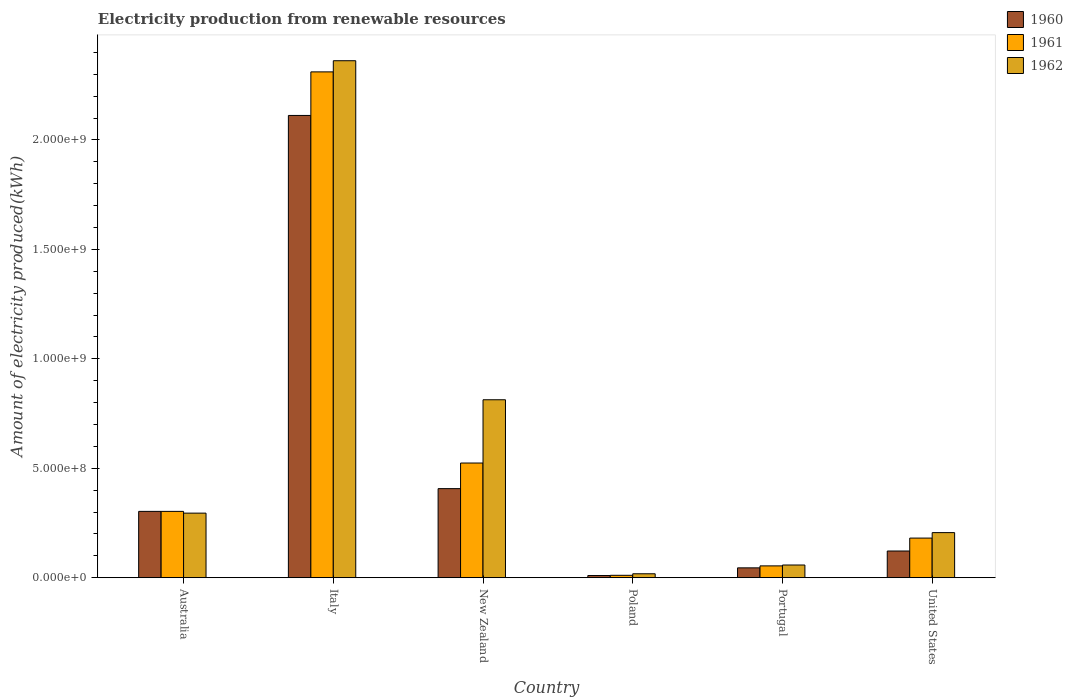How many different coloured bars are there?
Give a very brief answer. 3. How many bars are there on the 2nd tick from the left?
Provide a short and direct response. 3. What is the label of the 5th group of bars from the left?
Give a very brief answer. Portugal. In how many cases, is the number of bars for a given country not equal to the number of legend labels?
Ensure brevity in your answer.  0. What is the amount of electricity produced in 1961 in Italy?
Your response must be concise. 2.31e+09. Across all countries, what is the maximum amount of electricity produced in 1962?
Your answer should be compact. 2.36e+09. Across all countries, what is the minimum amount of electricity produced in 1962?
Ensure brevity in your answer.  1.80e+07. In which country was the amount of electricity produced in 1960 minimum?
Give a very brief answer. Poland. What is the total amount of electricity produced in 1961 in the graph?
Provide a short and direct response. 3.38e+09. What is the difference between the amount of electricity produced in 1960 in Italy and that in Poland?
Your response must be concise. 2.10e+09. What is the difference between the amount of electricity produced in 1960 in Portugal and the amount of electricity produced in 1961 in Poland?
Keep it short and to the point. 3.40e+07. What is the average amount of electricity produced in 1962 per country?
Your response must be concise. 6.25e+08. What is the difference between the amount of electricity produced of/in 1961 and amount of electricity produced of/in 1960 in Portugal?
Keep it short and to the point. 9.00e+06. In how many countries, is the amount of electricity produced in 1962 greater than 1900000000 kWh?
Ensure brevity in your answer.  1. What is the ratio of the amount of electricity produced in 1961 in New Zealand to that in Portugal?
Your answer should be very brief. 9.7. Is the difference between the amount of electricity produced in 1961 in New Zealand and Poland greater than the difference between the amount of electricity produced in 1960 in New Zealand and Poland?
Keep it short and to the point. Yes. What is the difference between the highest and the second highest amount of electricity produced in 1962?
Your response must be concise. 1.55e+09. What is the difference between the highest and the lowest amount of electricity produced in 1962?
Provide a succinct answer. 2.34e+09. In how many countries, is the amount of electricity produced in 1960 greater than the average amount of electricity produced in 1960 taken over all countries?
Provide a short and direct response. 1. What does the 1st bar from the left in Portugal represents?
Your answer should be very brief. 1960. What does the 3rd bar from the right in Portugal represents?
Provide a succinct answer. 1960. How many countries are there in the graph?
Provide a succinct answer. 6. How many legend labels are there?
Your answer should be very brief. 3. What is the title of the graph?
Provide a succinct answer. Electricity production from renewable resources. What is the label or title of the Y-axis?
Offer a terse response. Amount of electricity produced(kWh). What is the Amount of electricity produced(kWh) in 1960 in Australia?
Keep it short and to the point. 3.03e+08. What is the Amount of electricity produced(kWh) in 1961 in Australia?
Give a very brief answer. 3.03e+08. What is the Amount of electricity produced(kWh) in 1962 in Australia?
Keep it short and to the point. 2.95e+08. What is the Amount of electricity produced(kWh) of 1960 in Italy?
Provide a short and direct response. 2.11e+09. What is the Amount of electricity produced(kWh) in 1961 in Italy?
Keep it short and to the point. 2.31e+09. What is the Amount of electricity produced(kWh) in 1962 in Italy?
Make the answer very short. 2.36e+09. What is the Amount of electricity produced(kWh) of 1960 in New Zealand?
Offer a terse response. 4.07e+08. What is the Amount of electricity produced(kWh) in 1961 in New Zealand?
Keep it short and to the point. 5.24e+08. What is the Amount of electricity produced(kWh) of 1962 in New Zealand?
Give a very brief answer. 8.13e+08. What is the Amount of electricity produced(kWh) in 1960 in Poland?
Your answer should be very brief. 1.00e+07. What is the Amount of electricity produced(kWh) of 1961 in Poland?
Ensure brevity in your answer.  1.10e+07. What is the Amount of electricity produced(kWh) of 1962 in Poland?
Make the answer very short. 1.80e+07. What is the Amount of electricity produced(kWh) of 1960 in Portugal?
Your answer should be very brief. 4.50e+07. What is the Amount of electricity produced(kWh) of 1961 in Portugal?
Your response must be concise. 5.40e+07. What is the Amount of electricity produced(kWh) in 1962 in Portugal?
Give a very brief answer. 5.80e+07. What is the Amount of electricity produced(kWh) in 1960 in United States?
Your answer should be compact. 1.22e+08. What is the Amount of electricity produced(kWh) in 1961 in United States?
Ensure brevity in your answer.  1.81e+08. What is the Amount of electricity produced(kWh) of 1962 in United States?
Give a very brief answer. 2.06e+08. Across all countries, what is the maximum Amount of electricity produced(kWh) in 1960?
Give a very brief answer. 2.11e+09. Across all countries, what is the maximum Amount of electricity produced(kWh) in 1961?
Offer a terse response. 2.31e+09. Across all countries, what is the maximum Amount of electricity produced(kWh) of 1962?
Ensure brevity in your answer.  2.36e+09. Across all countries, what is the minimum Amount of electricity produced(kWh) of 1961?
Your response must be concise. 1.10e+07. Across all countries, what is the minimum Amount of electricity produced(kWh) of 1962?
Provide a succinct answer. 1.80e+07. What is the total Amount of electricity produced(kWh) of 1960 in the graph?
Keep it short and to the point. 3.00e+09. What is the total Amount of electricity produced(kWh) of 1961 in the graph?
Provide a short and direct response. 3.38e+09. What is the total Amount of electricity produced(kWh) in 1962 in the graph?
Your response must be concise. 3.75e+09. What is the difference between the Amount of electricity produced(kWh) of 1960 in Australia and that in Italy?
Your answer should be compact. -1.81e+09. What is the difference between the Amount of electricity produced(kWh) of 1961 in Australia and that in Italy?
Keep it short and to the point. -2.01e+09. What is the difference between the Amount of electricity produced(kWh) in 1962 in Australia and that in Italy?
Keep it short and to the point. -2.07e+09. What is the difference between the Amount of electricity produced(kWh) of 1960 in Australia and that in New Zealand?
Provide a short and direct response. -1.04e+08. What is the difference between the Amount of electricity produced(kWh) in 1961 in Australia and that in New Zealand?
Your response must be concise. -2.21e+08. What is the difference between the Amount of electricity produced(kWh) of 1962 in Australia and that in New Zealand?
Make the answer very short. -5.18e+08. What is the difference between the Amount of electricity produced(kWh) of 1960 in Australia and that in Poland?
Ensure brevity in your answer.  2.93e+08. What is the difference between the Amount of electricity produced(kWh) in 1961 in Australia and that in Poland?
Provide a short and direct response. 2.92e+08. What is the difference between the Amount of electricity produced(kWh) of 1962 in Australia and that in Poland?
Your response must be concise. 2.77e+08. What is the difference between the Amount of electricity produced(kWh) in 1960 in Australia and that in Portugal?
Keep it short and to the point. 2.58e+08. What is the difference between the Amount of electricity produced(kWh) of 1961 in Australia and that in Portugal?
Provide a succinct answer. 2.49e+08. What is the difference between the Amount of electricity produced(kWh) of 1962 in Australia and that in Portugal?
Your response must be concise. 2.37e+08. What is the difference between the Amount of electricity produced(kWh) of 1960 in Australia and that in United States?
Offer a very short reply. 1.81e+08. What is the difference between the Amount of electricity produced(kWh) of 1961 in Australia and that in United States?
Provide a short and direct response. 1.22e+08. What is the difference between the Amount of electricity produced(kWh) in 1962 in Australia and that in United States?
Your answer should be very brief. 8.90e+07. What is the difference between the Amount of electricity produced(kWh) in 1960 in Italy and that in New Zealand?
Make the answer very short. 1.70e+09. What is the difference between the Amount of electricity produced(kWh) in 1961 in Italy and that in New Zealand?
Ensure brevity in your answer.  1.79e+09. What is the difference between the Amount of electricity produced(kWh) in 1962 in Italy and that in New Zealand?
Offer a very short reply. 1.55e+09. What is the difference between the Amount of electricity produced(kWh) in 1960 in Italy and that in Poland?
Your answer should be compact. 2.10e+09. What is the difference between the Amount of electricity produced(kWh) in 1961 in Italy and that in Poland?
Your answer should be very brief. 2.30e+09. What is the difference between the Amount of electricity produced(kWh) in 1962 in Italy and that in Poland?
Provide a short and direct response. 2.34e+09. What is the difference between the Amount of electricity produced(kWh) of 1960 in Italy and that in Portugal?
Your answer should be very brief. 2.07e+09. What is the difference between the Amount of electricity produced(kWh) in 1961 in Italy and that in Portugal?
Keep it short and to the point. 2.26e+09. What is the difference between the Amount of electricity produced(kWh) of 1962 in Italy and that in Portugal?
Give a very brief answer. 2.30e+09. What is the difference between the Amount of electricity produced(kWh) of 1960 in Italy and that in United States?
Provide a succinct answer. 1.99e+09. What is the difference between the Amount of electricity produced(kWh) of 1961 in Italy and that in United States?
Ensure brevity in your answer.  2.13e+09. What is the difference between the Amount of electricity produced(kWh) in 1962 in Italy and that in United States?
Provide a succinct answer. 2.16e+09. What is the difference between the Amount of electricity produced(kWh) in 1960 in New Zealand and that in Poland?
Offer a very short reply. 3.97e+08. What is the difference between the Amount of electricity produced(kWh) of 1961 in New Zealand and that in Poland?
Offer a terse response. 5.13e+08. What is the difference between the Amount of electricity produced(kWh) of 1962 in New Zealand and that in Poland?
Provide a succinct answer. 7.95e+08. What is the difference between the Amount of electricity produced(kWh) in 1960 in New Zealand and that in Portugal?
Your answer should be very brief. 3.62e+08. What is the difference between the Amount of electricity produced(kWh) in 1961 in New Zealand and that in Portugal?
Offer a terse response. 4.70e+08. What is the difference between the Amount of electricity produced(kWh) of 1962 in New Zealand and that in Portugal?
Give a very brief answer. 7.55e+08. What is the difference between the Amount of electricity produced(kWh) in 1960 in New Zealand and that in United States?
Your response must be concise. 2.85e+08. What is the difference between the Amount of electricity produced(kWh) in 1961 in New Zealand and that in United States?
Make the answer very short. 3.43e+08. What is the difference between the Amount of electricity produced(kWh) of 1962 in New Zealand and that in United States?
Your answer should be very brief. 6.07e+08. What is the difference between the Amount of electricity produced(kWh) in 1960 in Poland and that in Portugal?
Your response must be concise. -3.50e+07. What is the difference between the Amount of electricity produced(kWh) in 1961 in Poland and that in Portugal?
Offer a very short reply. -4.30e+07. What is the difference between the Amount of electricity produced(kWh) in 1962 in Poland and that in Portugal?
Your answer should be very brief. -4.00e+07. What is the difference between the Amount of electricity produced(kWh) of 1960 in Poland and that in United States?
Offer a very short reply. -1.12e+08. What is the difference between the Amount of electricity produced(kWh) in 1961 in Poland and that in United States?
Give a very brief answer. -1.70e+08. What is the difference between the Amount of electricity produced(kWh) in 1962 in Poland and that in United States?
Offer a terse response. -1.88e+08. What is the difference between the Amount of electricity produced(kWh) of 1960 in Portugal and that in United States?
Offer a very short reply. -7.70e+07. What is the difference between the Amount of electricity produced(kWh) of 1961 in Portugal and that in United States?
Make the answer very short. -1.27e+08. What is the difference between the Amount of electricity produced(kWh) of 1962 in Portugal and that in United States?
Offer a very short reply. -1.48e+08. What is the difference between the Amount of electricity produced(kWh) in 1960 in Australia and the Amount of electricity produced(kWh) in 1961 in Italy?
Your response must be concise. -2.01e+09. What is the difference between the Amount of electricity produced(kWh) in 1960 in Australia and the Amount of electricity produced(kWh) in 1962 in Italy?
Your answer should be very brief. -2.06e+09. What is the difference between the Amount of electricity produced(kWh) of 1961 in Australia and the Amount of electricity produced(kWh) of 1962 in Italy?
Your answer should be very brief. -2.06e+09. What is the difference between the Amount of electricity produced(kWh) of 1960 in Australia and the Amount of electricity produced(kWh) of 1961 in New Zealand?
Offer a very short reply. -2.21e+08. What is the difference between the Amount of electricity produced(kWh) in 1960 in Australia and the Amount of electricity produced(kWh) in 1962 in New Zealand?
Your answer should be very brief. -5.10e+08. What is the difference between the Amount of electricity produced(kWh) of 1961 in Australia and the Amount of electricity produced(kWh) of 1962 in New Zealand?
Your answer should be compact. -5.10e+08. What is the difference between the Amount of electricity produced(kWh) of 1960 in Australia and the Amount of electricity produced(kWh) of 1961 in Poland?
Ensure brevity in your answer.  2.92e+08. What is the difference between the Amount of electricity produced(kWh) of 1960 in Australia and the Amount of electricity produced(kWh) of 1962 in Poland?
Provide a succinct answer. 2.85e+08. What is the difference between the Amount of electricity produced(kWh) in 1961 in Australia and the Amount of electricity produced(kWh) in 1962 in Poland?
Ensure brevity in your answer.  2.85e+08. What is the difference between the Amount of electricity produced(kWh) in 1960 in Australia and the Amount of electricity produced(kWh) in 1961 in Portugal?
Your answer should be compact. 2.49e+08. What is the difference between the Amount of electricity produced(kWh) in 1960 in Australia and the Amount of electricity produced(kWh) in 1962 in Portugal?
Provide a succinct answer. 2.45e+08. What is the difference between the Amount of electricity produced(kWh) in 1961 in Australia and the Amount of electricity produced(kWh) in 1962 in Portugal?
Give a very brief answer. 2.45e+08. What is the difference between the Amount of electricity produced(kWh) of 1960 in Australia and the Amount of electricity produced(kWh) of 1961 in United States?
Provide a succinct answer. 1.22e+08. What is the difference between the Amount of electricity produced(kWh) of 1960 in Australia and the Amount of electricity produced(kWh) of 1962 in United States?
Give a very brief answer. 9.70e+07. What is the difference between the Amount of electricity produced(kWh) of 1961 in Australia and the Amount of electricity produced(kWh) of 1962 in United States?
Your response must be concise. 9.70e+07. What is the difference between the Amount of electricity produced(kWh) of 1960 in Italy and the Amount of electricity produced(kWh) of 1961 in New Zealand?
Your answer should be compact. 1.59e+09. What is the difference between the Amount of electricity produced(kWh) of 1960 in Italy and the Amount of electricity produced(kWh) of 1962 in New Zealand?
Provide a short and direct response. 1.30e+09. What is the difference between the Amount of electricity produced(kWh) in 1961 in Italy and the Amount of electricity produced(kWh) in 1962 in New Zealand?
Ensure brevity in your answer.  1.50e+09. What is the difference between the Amount of electricity produced(kWh) in 1960 in Italy and the Amount of electricity produced(kWh) in 1961 in Poland?
Keep it short and to the point. 2.10e+09. What is the difference between the Amount of electricity produced(kWh) in 1960 in Italy and the Amount of electricity produced(kWh) in 1962 in Poland?
Provide a short and direct response. 2.09e+09. What is the difference between the Amount of electricity produced(kWh) of 1961 in Italy and the Amount of electricity produced(kWh) of 1962 in Poland?
Keep it short and to the point. 2.29e+09. What is the difference between the Amount of electricity produced(kWh) of 1960 in Italy and the Amount of electricity produced(kWh) of 1961 in Portugal?
Offer a terse response. 2.06e+09. What is the difference between the Amount of electricity produced(kWh) in 1960 in Italy and the Amount of electricity produced(kWh) in 1962 in Portugal?
Offer a very short reply. 2.05e+09. What is the difference between the Amount of electricity produced(kWh) of 1961 in Italy and the Amount of electricity produced(kWh) of 1962 in Portugal?
Your answer should be very brief. 2.25e+09. What is the difference between the Amount of electricity produced(kWh) in 1960 in Italy and the Amount of electricity produced(kWh) in 1961 in United States?
Give a very brief answer. 1.93e+09. What is the difference between the Amount of electricity produced(kWh) of 1960 in Italy and the Amount of electricity produced(kWh) of 1962 in United States?
Your answer should be very brief. 1.91e+09. What is the difference between the Amount of electricity produced(kWh) of 1961 in Italy and the Amount of electricity produced(kWh) of 1962 in United States?
Your answer should be very brief. 2.10e+09. What is the difference between the Amount of electricity produced(kWh) in 1960 in New Zealand and the Amount of electricity produced(kWh) in 1961 in Poland?
Ensure brevity in your answer.  3.96e+08. What is the difference between the Amount of electricity produced(kWh) of 1960 in New Zealand and the Amount of electricity produced(kWh) of 1962 in Poland?
Your answer should be compact. 3.89e+08. What is the difference between the Amount of electricity produced(kWh) of 1961 in New Zealand and the Amount of electricity produced(kWh) of 1962 in Poland?
Your answer should be very brief. 5.06e+08. What is the difference between the Amount of electricity produced(kWh) in 1960 in New Zealand and the Amount of electricity produced(kWh) in 1961 in Portugal?
Ensure brevity in your answer.  3.53e+08. What is the difference between the Amount of electricity produced(kWh) of 1960 in New Zealand and the Amount of electricity produced(kWh) of 1962 in Portugal?
Make the answer very short. 3.49e+08. What is the difference between the Amount of electricity produced(kWh) in 1961 in New Zealand and the Amount of electricity produced(kWh) in 1962 in Portugal?
Offer a very short reply. 4.66e+08. What is the difference between the Amount of electricity produced(kWh) of 1960 in New Zealand and the Amount of electricity produced(kWh) of 1961 in United States?
Provide a short and direct response. 2.26e+08. What is the difference between the Amount of electricity produced(kWh) of 1960 in New Zealand and the Amount of electricity produced(kWh) of 1962 in United States?
Offer a terse response. 2.01e+08. What is the difference between the Amount of electricity produced(kWh) of 1961 in New Zealand and the Amount of electricity produced(kWh) of 1962 in United States?
Make the answer very short. 3.18e+08. What is the difference between the Amount of electricity produced(kWh) in 1960 in Poland and the Amount of electricity produced(kWh) in 1961 in Portugal?
Give a very brief answer. -4.40e+07. What is the difference between the Amount of electricity produced(kWh) in 1960 in Poland and the Amount of electricity produced(kWh) in 1962 in Portugal?
Your answer should be very brief. -4.80e+07. What is the difference between the Amount of electricity produced(kWh) of 1961 in Poland and the Amount of electricity produced(kWh) of 1962 in Portugal?
Your answer should be compact. -4.70e+07. What is the difference between the Amount of electricity produced(kWh) in 1960 in Poland and the Amount of electricity produced(kWh) in 1961 in United States?
Make the answer very short. -1.71e+08. What is the difference between the Amount of electricity produced(kWh) of 1960 in Poland and the Amount of electricity produced(kWh) of 1962 in United States?
Keep it short and to the point. -1.96e+08. What is the difference between the Amount of electricity produced(kWh) of 1961 in Poland and the Amount of electricity produced(kWh) of 1962 in United States?
Provide a short and direct response. -1.95e+08. What is the difference between the Amount of electricity produced(kWh) in 1960 in Portugal and the Amount of electricity produced(kWh) in 1961 in United States?
Provide a succinct answer. -1.36e+08. What is the difference between the Amount of electricity produced(kWh) in 1960 in Portugal and the Amount of electricity produced(kWh) in 1962 in United States?
Provide a succinct answer. -1.61e+08. What is the difference between the Amount of electricity produced(kWh) of 1961 in Portugal and the Amount of electricity produced(kWh) of 1962 in United States?
Your answer should be very brief. -1.52e+08. What is the average Amount of electricity produced(kWh) in 1960 per country?
Keep it short and to the point. 5.00e+08. What is the average Amount of electricity produced(kWh) of 1961 per country?
Offer a terse response. 5.64e+08. What is the average Amount of electricity produced(kWh) of 1962 per country?
Offer a terse response. 6.25e+08. What is the difference between the Amount of electricity produced(kWh) in 1960 and Amount of electricity produced(kWh) in 1961 in Italy?
Give a very brief answer. -1.99e+08. What is the difference between the Amount of electricity produced(kWh) in 1960 and Amount of electricity produced(kWh) in 1962 in Italy?
Ensure brevity in your answer.  -2.50e+08. What is the difference between the Amount of electricity produced(kWh) in 1961 and Amount of electricity produced(kWh) in 1962 in Italy?
Make the answer very short. -5.10e+07. What is the difference between the Amount of electricity produced(kWh) of 1960 and Amount of electricity produced(kWh) of 1961 in New Zealand?
Make the answer very short. -1.17e+08. What is the difference between the Amount of electricity produced(kWh) of 1960 and Amount of electricity produced(kWh) of 1962 in New Zealand?
Your answer should be very brief. -4.06e+08. What is the difference between the Amount of electricity produced(kWh) of 1961 and Amount of electricity produced(kWh) of 1962 in New Zealand?
Ensure brevity in your answer.  -2.89e+08. What is the difference between the Amount of electricity produced(kWh) of 1960 and Amount of electricity produced(kWh) of 1961 in Poland?
Ensure brevity in your answer.  -1.00e+06. What is the difference between the Amount of electricity produced(kWh) of 1960 and Amount of electricity produced(kWh) of 1962 in Poland?
Offer a very short reply. -8.00e+06. What is the difference between the Amount of electricity produced(kWh) of 1961 and Amount of electricity produced(kWh) of 1962 in Poland?
Offer a very short reply. -7.00e+06. What is the difference between the Amount of electricity produced(kWh) in 1960 and Amount of electricity produced(kWh) in 1961 in Portugal?
Make the answer very short. -9.00e+06. What is the difference between the Amount of electricity produced(kWh) in 1960 and Amount of electricity produced(kWh) in 1962 in Portugal?
Ensure brevity in your answer.  -1.30e+07. What is the difference between the Amount of electricity produced(kWh) in 1960 and Amount of electricity produced(kWh) in 1961 in United States?
Offer a terse response. -5.90e+07. What is the difference between the Amount of electricity produced(kWh) in 1960 and Amount of electricity produced(kWh) in 1962 in United States?
Give a very brief answer. -8.40e+07. What is the difference between the Amount of electricity produced(kWh) in 1961 and Amount of electricity produced(kWh) in 1962 in United States?
Your answer should be very brief. -2.50e+07. What is the ratio of the Amount of electricity produced(kWh) in 1960 in Australia to that in Italy?
Offer a very short reply. 0.14. What is the ratio of the Amount of electricity produced(kWh) of 1961 in Australia to that in Italy?
Your answer should be very brief. 0.13. What is the ratio of the Amount of electricity produced(kWh) of 1962 in Australia to that in Italy?
Give a very brief answer. 0.12. What is the ratio of the Amount of electricity produced(kWh) of 1960 in Australia to that in New Zealand?
Provide a succinct answer. 0.74. What is the ratio of the Amount of electricity produced(kWh) of 1961 in Australia to that in New Zealand?
Your answer should be compact. 0.58. What is the ratio of the Amount of electricity produced(kWh) of 1962 in Australia to that in New Zealand?
Ensure brevity in your answer.  0.36. What is the ratio of the Amount of electricity produced(kWh) of 1960 in Australia to that in Poland?
Keep it short and to the point. 30.3. What is the ratio of the Amount of electricity produced(kWh) in 1961 in Australia to that in Poland?
Your answer should be compact. 27.55. What is the ratio of the Amount of electricity produced(kWh) in 1962 in Australia to that in Poland?
Your answer should be compact. 16.39. What is the ratio of the Amount of electricity produced(kWh) of 1960 in Australia to that in Portugal?
Provide a short and direct response. 6.73. What is the ratio of the Amount of electricity produced(kWh) of 1961 in Australia to that in Portugal?
Offer a terse response. 5.61. What is the ratio of the Amount of electricity produced(kWh) of 1962 in Australia to that in Portugal?
Make the answer very short. 5.09. What is the ratio of the Amount of electricity produced(kWh) of 1960 in Australia to that in United States?
Offer a terse response. 2.48. What is the ratio of the Amount of electricity produced(kWh) of 1961 in Australia to that in United States?
Make the answer very short. 1.67. What is the ratio of the Amount of electricity produced(kWh) in 1962 in Australia to that in United States?
Your response must be concise. 1.43. What is the ratio of the Amount of electricity produced(kWh) of 1960 in Italy to that in New Zealand?
Offer a terse response. 5.19. What is the ratio of the Amount of electricity produced(kWh) in 1961 in Italy to that in New Zealand?
Provide a short and direct response. 4.41. What is the ratio of the Amount of electricity produced(kWh) of 1962 in Italy to that in New Zealand?
Offer a very short reply. 2.91. What is the ratio of the Amount of electricity produced(kWh) in 1960 in Italy to that in Poland?
Keep it short and to the point. 211.2. What is the ratio of the Amount of electricity produced(kWh) in 1961 in Italy to that in Poland?
Your answer should be very brief. 210.09. What is the ratio of the Amount of electricity produced(kWh) in 1962 in Italy to that in Poland?
Ensure brevity in your answer.  131.22. What is the ratio of the Amount of electricity produced(kWh) of 1960 in Italy to that in Portugal?
Your response must be concise. 46.93. What is the ratio of the Amount of electricity produced(kWh) in 1961 in Italy to that in Portugal?
Your answer should be compact. 42.8. What is the ratio of the Amount of electricity produced(kWh) in 1962 in Italy to that in Portugal?
Your response must be concise. 40.72. What is the ratio of the Amount of electricity produced(kWh) in 1960 in Italy to that in United States?
Your answer should be compact. 17.31. What is the ratio of the Amount of electricity produced(kWh) in 1961 in Italy to that in United States?
Ensure brevity in your answer.  12.77. What is the ratio of the Amount of electricity produced(kWh) in 1962 in Italy to that in United States?
Make the answer very short. 11.47. What is the ratio of the Amount of electricity produced(kWh) in 1960 in New Zealand to that in Poland?
Give a very brief answer. 40.7. What is the ratio of the Amount of electricity produced(kWh) in 1961 in New Zealand to that in Poland?
Your answer should be compact. 47.64. What is the ratio of the Amount of electricity produced(kWh) of 1962 in New Zealand to that in Poland?
Your answer should be compact. 45.17. What is the ratio of the Amount of electricity produced(kWh) in 1960 in New Zealand to that in Portugal?
Keep it short and to the point. 9.04. What is the ratio of the Amount of electricity produced(kWh) of 1961 in New Zealand to that in Portugal?
Your response must be concise. 9.7. What is the ratio of the Amount of electricity produced(kWh) in 1962 in New Zealand to that in Portugal?
Offer a very short reply. 14.02. What is the ratio of the Amount of electricity produced(kWh) of 1960 in New Zealand to that in United States?
Your answer should be compact. 3.34. What is the ratio of the Amount of electricity produced(kWh) of 1961 in New Zealand to that in United States?
Your response must be concise. 2.9. What is the ratio of the Amount of electricity produced(kWh) in 1962 in New Zealand to that in United States?
Give a very brief answer. 3.95. What is the ratio of the Amount of electricity produced(kWh) of 1960 in Poland to that in Portugal?
Make the answer very short. 0.22. What is the ratio of the Amount of electricity produced(kWh) of 1961 in Poland to that in Portugal?
Keep it short and to the point. 0.2. What is the ratio of the Amount of electricity produced(kWh) in 1962 in Poland to that in Portugal?
Your answer should be compact. 0.31. What is the ratio of the Amount of electricity produced(kWh) of 1960 in Poland to that in United States?
Offer a very short reply. 0.08. What is the ratio of the Amount of electricity produced(kWh) of 1961 in Poland to that in United States?
Offer a very short reply. 0.06. What is the ratio of the Amount of electricity produced(kWh) in 1962 in Poland to that in United States?
Give a very brief answer. 0.09. What is the ratio of the Amount of electricity produced(kWh) of 1960 in Portugal to that in United States?
Keep it short and to the point. 0.37. What is the ratio of the Amount of electricity produced(kWh) of 1961 in Portugal to that in United States?
Provide a succinct answer. 0.3. What is the ratio of the Amount of electricity produced(kWh) of 1962 in Portugal to that in United States?
Your answer should be compact. 0.28. What is the difference between the highest and the second highest Amount of electricity produced(kWh) in 1960?
Offer a terse response. 1.70e+09. What is the difference between the highest and the second highest Amount of electricity produced(kWh) of 1961?
Your answer should be very brief. 1.79e+09. What is the difference between the highest and the second highest Amount of electricity produced(kWh) in 1962?
Your answer should be compact. 1.55e+09. What is the difference between the highest and the lowest Amount of electricity produced(kWh) of 1960?
Your response must be concise. 2.10e+09. What is the difference between the highest and the lowest Amount of electricity produced(kWh) in 1961?
Your response must be concise. 2.30e+09. What is the difference between the highest and the lowest Amount of electricity produced(kWh) in 1962?
Give a very brief answer. 2.34e+09. 